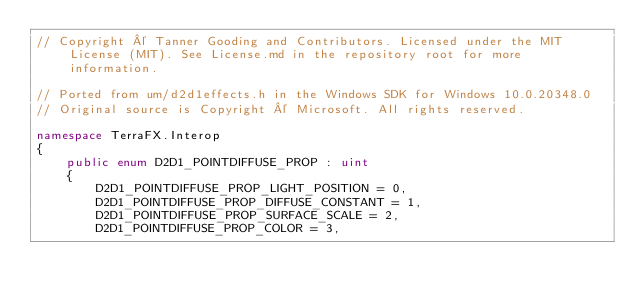Convert code to text. <code><loc_0><loc_0><loc_500><loc_500><_C#_>// Copyright © Tanner Gooding and Contributors. Licensed under the MIT License (MIT). See License.md in the repository root for more information.

// Ported from um/d2d1effects.h in the Windows SDK for Windows 10.0.20348.0
// Original source is Copyright © Microsoft. All rights reserved.

namespace TerraFX.Interop
{
    public enum D2D1_POINTDIFFUSE_PROP : uint
    {
        D2D1_POINTDIFFUSE_PROP_LIGHT_POSITION = 0,
        D2D1_POINTDIFFUSE_PROP_DIFFUSE_CONSTANT = 1,
        D2D1_POINTDIFFUSE_PROP_SURFACE_SCALE = 2,
        D2D1_POINTDIFFUSE_PROP_COLOR = 3,</code> 